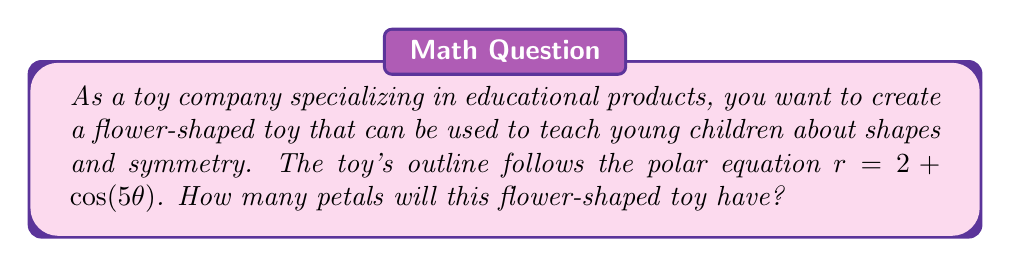Teach me how to tackle this problem. To determine the number of petals in the flower-shaped toy, we need to analyze the given polar equation:

$r = 2 + \cos(5\theta)$

1. In polar equations of the form $r = a + b\cos(n\theta)$ or $r = a + b\sin(n\theta)$, where $a$ and $b$ are constants and $n$ is an integer, the value of $n$ determines the number of petals or lobes in the shape.

2. In this case, we have $a = 2$, $b = 1$, and $n = 5$.

3. The number of petals is determined by the value of $n$ when $n$ is odd. Specifically, for odd values of $n$, the number of petals is equal to $n$.

4. Since $n = 5$ in our equation, the flower-shaped toy will have 5 petals.

5. To visualize this, we can consider that the cosine function completes one full cycle every $2\pi$ radians. With $5\theta$ in the equation, it will complete 5 cycles as $\theta$ goes from 0 to $2\pi$, resulting in 5 petals.

[asy]
import graph;
size(200);

real r(real theta) {
  return 2 + cos(5*theta);
}

path flower;
for (real t = 0; t <= 2*pi; t += 0.01) {
  pair z = r(t) * dir(t * 180 / pi);
  flower = flower -- z;
}

draw(flower, red);
label("5 petals", (0,2.5), N);
[/asy]

The diagram above illustrates the shape of the toy, clearly showing 5 petals.
Answer: The flower-shaped toy will have 5 petals. 